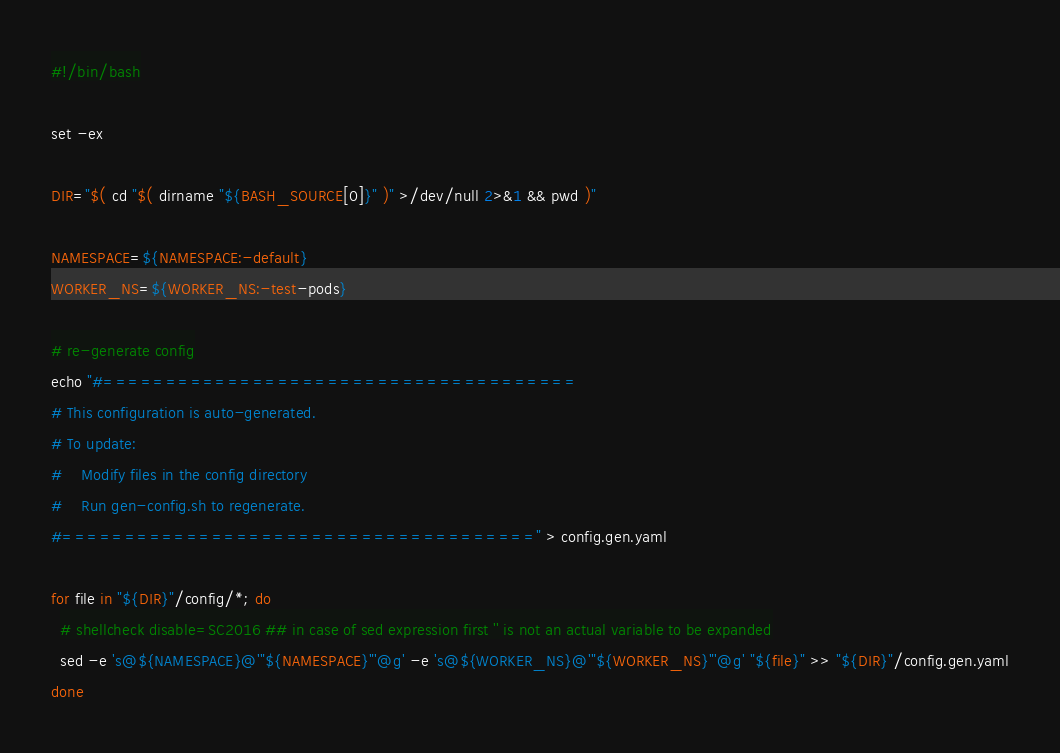Convert code to text. <code><loc_0><loc_0><loc_500><loc_500><_Bash_>#!/bin/bash

set -ex

DIR="$( cd "$( dirname "${BASH_SOURCE[0]}" )" >/dev/null 2>&1 && pwd )"

NAMESPACE=${NAMESPACE:-default}
WORKER_NS=${WORKER_NS:-test-pods}

# re-generate config
echo "#======================================
# This configuration is auto-generated. 
# To update:
#    Modify files in the config directory
#    Run gen-config.sh to regenerate.
#======================================" > config.gen.yaml

for file in "${DIR}"/config/*; do
  # shellcheck disable=SC2016 ## in case of sed expression first '' is not an actual variable to be expanded
  sed -e 's@${NAMESPACE}@'"${NAMESPACE}"'@g' -e 's@${WORKER_NS}@'"${WORKER_NS}"'@g' "${file}" >> "${DIR}"/config.gen.yaml
done
</code> 